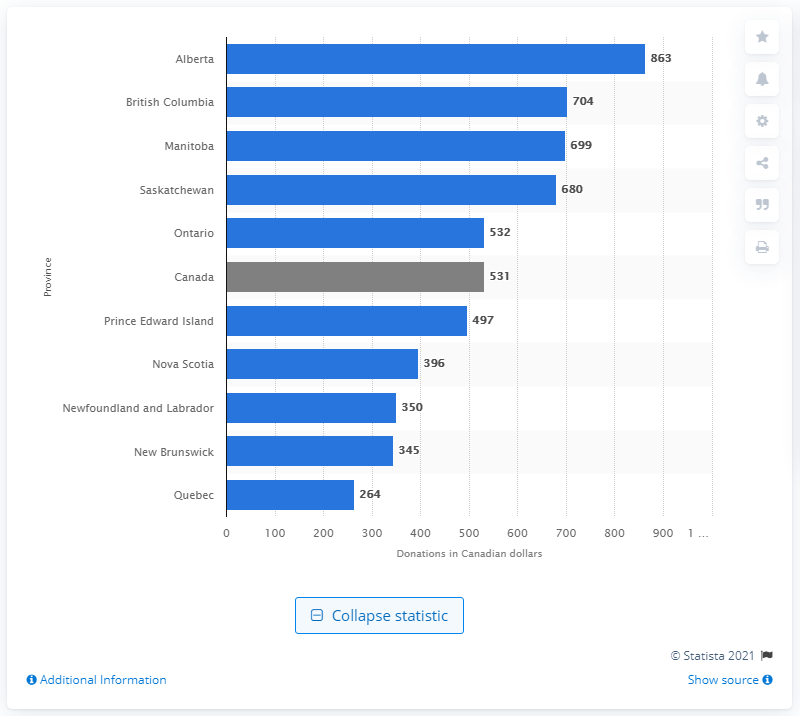Give some essential details in this illustration. In 2013, the average amount of Canadian dollars given to charities in Alberta was 863. 